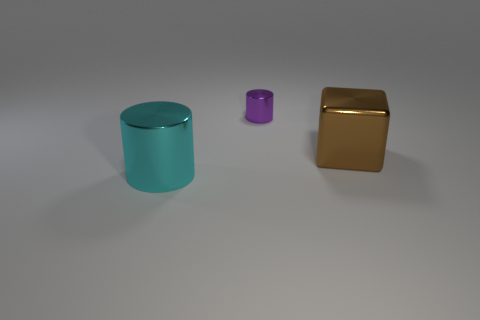Can you speculate on the materials these objects might be made from? Based on the appearance, the cyan and purple objects could be made of colored glass or plastic due to their translucency, while the golden object might be made from a metallic material given its reflective surface. 